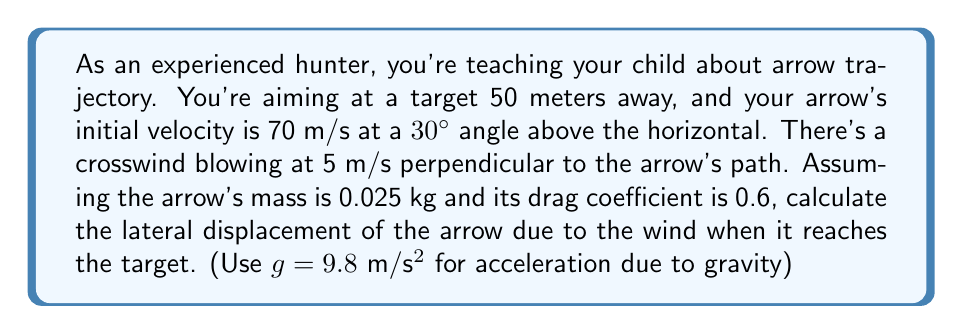Provide a solution to this math problem. Let's approach this step-by-step:

1) First, we need to calculate the time it takes for the arrow to reach the target. We can use the horizontal component of the velocity for this:

   $v_x = v \cos \theta = 70 \cos 30° = 60.62$ m/s

   Time to reach target: $t = \frac{distance}{v_x} = \frac{50}{60.62} = 0.825$ seconds

2) Now, we need to calculate the force of the wind on the arrow. The force due to wind is given by:

   $F = \frac{1}{2} \rho C_d A v^2$

   Where $\rho$ is air density (approximately 1.225 kg/m³), $C_d$ is the drag coefficient (0.6), $A$ is the cross-sectional area of the arrow (let's assume it's 0.0001 m²), and $v$ is the wind velocity (5 m/s).

   $F = \frac{1}{2} (1.225)(0.6)(0.0001)(5^2) = 0.0009188$ N

3) Using Newton's second law, we can calculate the acceleration of the arrow due to this force:

   $a = \frac{F}{m} = \frac{0.0009188}{0.025} = 0.0368$ m/s²

4) Now we can use the equation for displacement due to constant acceleration:

   $x = \frac{1}{2}at^2$

   Where $x$ is the lateral displacement, $a$ is the acceleration we just calculated, and $t$ is the time we calculated in step 1.

   $x = \frac{1}{2}(0.0368)(0.825^2) = 0.0125$ m

Therefore, the lateral displacement of the arrow due to the wind when it reaches the target is approximately 0.0125 meters or 1.25 cm.
Answer: The lateral displacement of the arrow due to the wind is approximately 0.0125 meters or 1.25 cm. 